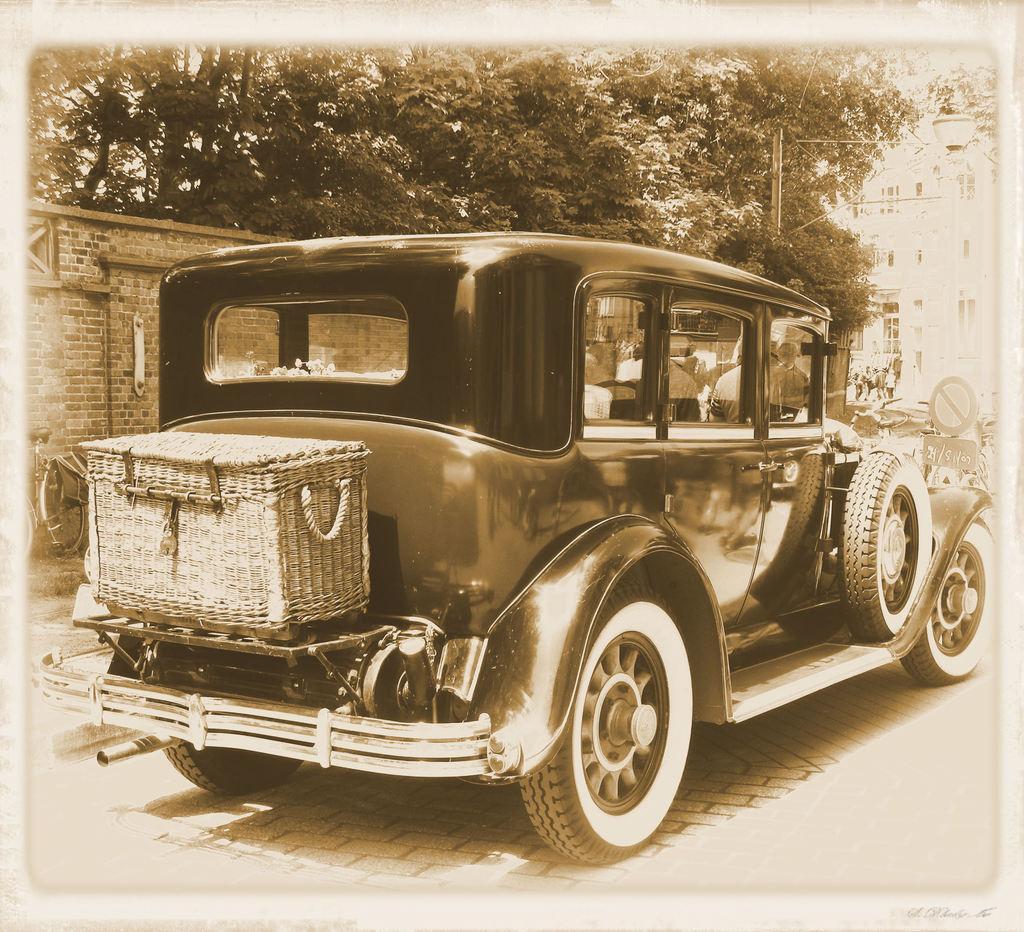Can you describe this image briefly? In the picture I can see a basket it is placed here, we can see an old car on the road, we can see the brick wall, trees, caution board and buildings in the background. 